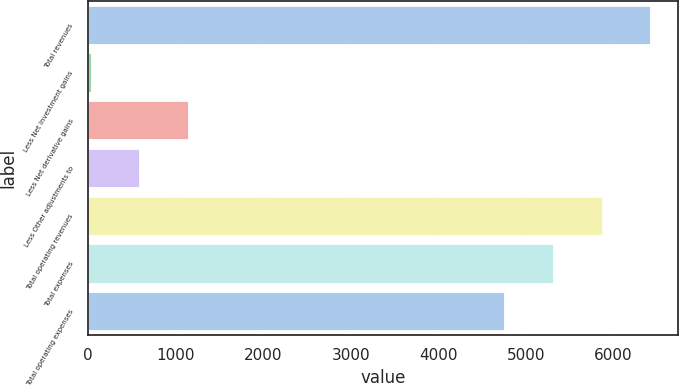Convert chart to OTSL. <chart><loc_0><loc_0><loc_500><loc_500><bar_chart><fcel>Total revenues<fcel>Less Net investment gains<fcel>Less Net derivative gains<fcel>Less Other adjustments to<fcel>Total operating revenues<fcel>Total expenses<fcel>Total operating expenses<nl><fcel>6419.4<fcel>30<fcel>1143.6<fcel>586.8<fcel>5862.6<fcel>5305.8<fcel>4749<nl></chart> 